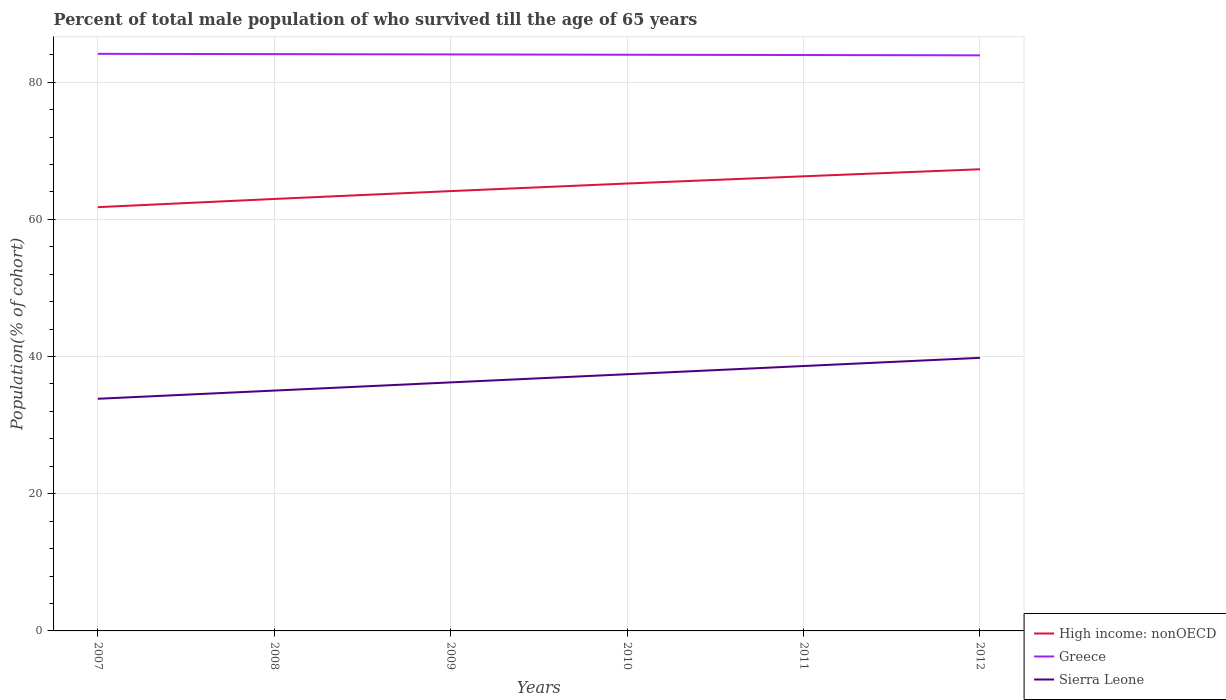Is the number of lines equal to the number of legend labels?
Provide a short and direct response. Yes. Across all years, what is the maximum percentage of total male population who survived till the age of 65 years in High income: nonOECD?
Provide a succinct answer. 61.77. What is the total percentage of total male population who survived till the age of 65 years in Greece in the graph?
Your response must be concise. 0.18. What is the difference between the highest and the second highest percentage of total male population who survived till the age of 65 years in Sierra Leone?
Offer a very short reply. 5.96. Is the percentage of total male population who survived till the age of 65 years in Greece strictly greater than the percentage of total male population who survived till the age of 65 years in High income: nonOECD over the years?
Offer a very short reply. No. How many years are there in the graph?
Offer a terse response. 6. What is the difference between two consecutive major ticks on the Y-axis?
Offer a very short reply. 20. Does the graph contain any zero values?
Your answer should be compact. No. Does the graph contain grids?
Make the answer very short. Yes. How many legend labels are there?
Offer a terse response. 3. How are the legend labels stacked?
Provide a succinct answer. Vertical. What is the title of the graph?
Your answer should be very brief. Percent of total male population of who survived till the age of 65 years. Does "Netherlands" appear as one of the legend labels in the graph?
Your answer should be very brief. No. What is the label or title of the X-axis?
Offer a very short reply. Years. What is the label or title of the Y-axis?
Make the answer very short. Population(% of cohort). What is the Population(% of cohort) in High income: nonOECD in 2007?
Make the answer very short. 61.77. What is the Population(% of cohort) in Greece in 2007?
Offer a very short reply. 84.13. What is the Population(% of cohort) in Sierra Leone in 2007?
Your answer should be compact. 33.84. What is the Population(% of cohort) in High income: nonOECD in 2008?
Keep it short and to the point. 62.97. What is the Population(% of cohort) in Greece in 2008?
Provide a succinct answer. 84.08. What is the Population(% of cohort) in Sierra Leone in 2008?
Make the answer very short. 35.04. What is the Population(% of cohort) of High income: nonOECD in 2009?
Your response must be concise. 64.12. What is the Population(% of cohort) in Greece in 2009?
Your answer should be very brief. 84.04. What is the Population(% of cohort) in Sierra Leone in 2009?
Your answer should be compact. 36.23. What is the Population(% of cohort) in High income: nonOECD in 2010?
Provide a short and direct response. 65.22. What is the Population(% of cohort) in Greece in 2010?
Ensure brevity in your answer.  83.99. What is the Population(% of cohort) in Sierra Leone in 2010?
Your answer should be compact. 37.42. What is the Population(% of cohort) of High income: nonOECD in 2011?
Offer a very short reply. 66.27. What is the Population(% of cohort) in Greece in 2011?
Give a very brief answer. 83.95. What is the Population(% of cohort) in Sierra Leone in 2011?
Give a very brief answer. 38.61. What is the Population(% of cohort) of High income: nonOECD in 2012?
Ensure brevity in your answer.  67.3. What is the Population(% of cohort) in Greece in 2012?
Give a very brief answer. 83.91. What is the Population(% of cohort) of Sierra Leone in 2012?
Offer a terse response. 39.81. Across all years, what is the maximum Population(% of cohort) in High income: nonOECD?
Provide a succinct answer. 67.3. Across all years, what is the maximum Population(% of cohort) of Greece?
Your answer should be compact. 84.13. Across all years, what is the maximum Population(% of cohort) of Sierra Leone?
Ensure brevity in your answer.  39.81. Across all years, what is the minimum Population(% of cohort) in High income: nonOECD?
Your response must be concise. 61.77. Across all years, what is the minimum Population(% of cohort) in Greece?
Your answer should be compact. 83.91. Across all years, what is the minimum Population(% of cohort) of Sierra Leone?
Ensure brevity in your answer.  33.84. What is the total Population(% of cohort) in High income: nonOECD in the graph?
Provide a short and direct response. 387.65. What is the total Population(% of cohort) of Greece in the graph?
Your response must be concise. 504.1. What is the total Population(% of cohort) of Sierra Leone in the graph?
Give a very brief answer. 220.95. What is the difference between the Population(% of cohort) of High income: nonOECD in 2007 and that in 2008?
Your answer should be very brief. -1.2. What is the difference between the Population(% of cohort) of Greece in 2007 and that in 2008?
Offer a terse response. 0.04. What is the difference between the Population(% of cohort) of Sierra Leone in 2007 and that in 2008?
Ensure brevity in your answer.  -1.19. What is the difference between the Population(% of cohort) in High income: nonOECD in 2007 and that in 2009?
Make the answer very short. -2.34. What is the difference between the Population(% of cohort) in Greece in 2007 and that in 2009?
Your response must be concise. 0.09. What is the difference between the Population(% of cohort) of Sierra Leone in 2007 and that in 2009?
Your answer should be very brief. -2.39. What is the difference between the Population(% of cohort) of High income: nonOECD in 2007 and that in 2010?
Your response must be concise. -3.45. What is the difference between the Population(% of cohort) in Greece in 2007 and that in 2010?
Offer a very short reply. 0.13. What is the difference between the Population(% of cohort) of Sierra Leone in 2007 and that in 2010?
Provide a succinct answer. -3.58. What is the difference between the Population(% of cohort) of High income: nonOECD in 2007 and that in 2011?
Keep it short and to the point. -4.5. What is the difference between the Population(% of cohort) of Greece in 2007 and that in 2011?
Your answer should be compact. 0.18. What is the difference between the Population(% of cohort) in Sierra Leone in 2007 and that in 2011?
Provide a succinct answer. -4.77. What is the difference between the Population(% of cohort) of High income: nonOECD in 2007 and that in 2012?
Ensure brevity in your answer.  -5.52. What is the difference between the Population(% of cohort) of Greece in 2007 and that in 2012?
Your response must be concise. 0.22. What is the difference between the Population(% of cohort) in Sierra Leone in 2007 and that in 2012?
Keep it short and to the point. -5.96. What is the difference between the Population(% of cohort) in High income: nonOECD in 2008 and that in 2009?
Your response must be concise. -1.15. What is the difference between the Population(% of cohort) of Greece in 2008 and that in 2009?
Keep it short and to the point. 0.04. What is the difference between the Population(% of cohort) in Sierra Leone in 2008 and that in 2009?
Offer a very short reply. -1.19. What is the difference between the Population(% of cohort) of High income: nonOECD in 2008 and that in 2010?
Your answer should be very brief. -2.25. What is the difference between the Population(% of cohort) in Greece in 2008 and that in 2010?
Your response must be concise. 0.09. What is the difference between the Population(% of cohort) in Sierra Leone in 2008 and that in 2010?
Give a very brief answer. -2.39. What is the difference between the Population(% of cohort) of High income: nonOECD in 2008 and that in 2011?
Give a very brief answer. -3.3. What is the difference between the Population(% of cohort) of Greece in 2008 and that in 2011?
Ensure brevity in your answer.  0.13. What is the difference between the Population(% of cohort) in Sierra Leone in 2008 and that in 2011?
Your answer should be compact. -3.58. What is the difference between the Population(% of cohort) of High income: nonOECD in 2008 and that in 2012?
Your answer should be compact. -4.33. What is the difference between the Population(% of cohort) in Greece in 2008 and that in 2012?
Your answer should be compact. 0.18. What is the difference between the Population(% of cohort) of Sierra Leone in 2008 and that in 2012?
Provide a succinct answer. -4.77. What is the difference between the Population(% of cohort) in High income: nonOECD in 2009 and that in 2010?
Your answer should be compact. -1.1. What is the difference between the Population(% of cohort) in Greece in 2009 and that in 2010?
Make the answer very short. 0.04. What is the difference between the Population(% of cohort) of Sierra Leone in 2009 and that in 2010?
Make the answer very short. -1.19. What is the difference between the Population(% of cohort) in High income: nonOECD in 2009 and that in 2011?
Offer a very short reply. -2.16. What is the difference between the Population(% of cohort) of Greece in 2009 and that in 2011?
Your answer should be very brief. 0.09. What is the difference between the Population(% of cohort) of Sierra Leone in 2009 and that in 2011?
Your response must be concise. -2.39. What is the difference between the Population(% of cohort) in High income: nonOECD in 2009 and that in 2012?
Ensure brevity in your answer.  -3.18. What is the difference between the Population(% of cohort) in Greece in 2009 and that in 2012?
Ensure brevity in your answer.  0.13. What is the difference between the Population(% of cohort) in Sierra Leone in 2009 and that in 2012?
Give a very brief answer. -3.58. What is the difference between the Population(% of cohort) of High income: nonOECD in 2010 and that in 2011?
Provide a succinct answer. -1.05. What is the difference between the Population(% of cohort) of Greece in 2010 and that in 2011?
Offer a terse response. 0.04. What is the difference between the Population(% of cohort) of Sierra Leone in 2010 and that in 2011?
Your answer should be compact. -1.19. What is the difference between the Population(% of cohort) of High income: nonOECD in 2010 and that in 2012?
Your response must be concise. -2.08. What is the difference between the Population(% of cohort) in Greece in 2010 and that in 2012?
Offer a very short reply. 0.09. What is the difference between the Population(% of cohort) in Sierra Leone in 2010 and that in 2012?
Your answer should be very brief. -2.39. What is the difference between the Population(% of cohort) of High income: nonOECD in 2011 and that in 2012?
Offer a terse response. -1.03. What is the difference between the Population(% of cohort) in Greece in 2011 and that in 2012?
Make the answer very short. 0.04. What is the difference between the Population(% of cohort) in Sierra Leone in 2011 and that in 2012?
Give a very brief answer. -1.19. What is the difference between the Population(% of cohort) of High income: nonOECD in 2007 and the Population(% of cohort) of Greece in 2008?
Your answer should be very brief. -22.31. What is the difference between the Population(% of cohort) of High income: nonOECD in 2007 and the Population(% of cohort) of Sierra Leone in 2008?
Give a very brief answer. 26.74. What is the difference between the Population(% of cohort) in Greece in 2007 and the Population(% of cohort) in Sierra Leone in 2008?
Give a very brief answer. 49.09. What is the difference between the Population(% of cohort) of High income: nonOECD in 2007 and the Population(% of cohort) of Greece in 2009?
Ensure brevity in your answer.  -22.26. What is the difference between the Population(% of cohort) in High income: nonOECD in 2007 and the Population(% of cohort) in Sierra Leone in 2009?
Make the answer very short. 25.55. What is the difference between the Population(% of cohort) of Greece in 2007 and the Population(% of cohort) of Sierra Leone in 2009?
Offer a terse response. 47.9. What is the difference between the Population(% of cohort) of High income: nonOECD in 2007 and the Population(% of cohort) of Greece in 2010?
Provide a succinct answer. -22.22. What is the difference between the Population(% of cohort) of High income: nonOECD in 2007 and the Population(% of cohort) of Sierra Leone in 2010?
Your answer should be very brief. 24.35. What is the difference between the Population(% of cohort) of Greece in 2007 and the Population(% of cohort) of Sierra Leone in 2010?
Your answer should be compact. 46.7. What is the difference between the Population(% of cohort) of High income: nonOECD in 2007 and the Population(% of cohort) of Greece in 2011?
Keep it short and to the point. -22.18. What is the difference between the Population(% of cohort) in High income: nonOECD in 2007 and the Population(% of cohort) in Sierra Leone in 2011?
Make the answer very short. 23.16. What is the difference between the Population(% of cohort) in Greece in 2007 and the Population(% of cohort) in Sierra Leone in 2011?
Give a very brief answer. 45.51. What is the difference between the Population(% of cohort) in High income: nonOECD in 2007 and the Population(% of cohort) in Greece in 2012?
Provide a short and direct response. -22.13. What is the difference between the Population(% of cohort) in High income: nonOECD in 2007 and the Population(% of cohort) in Sierra Leone in 2012?
Provide a succinct answer. 21.97. What is the difference between the Population(% of cohort) of Greece in 2007 and the Population(% of cohort) of Sierra Leone in 2012?
Provide a short and direct response. 44.32. What is the difference between the Population(% of cohort) of High income: nonOECD in 2008 and the Population(% of cohort) of Greece in 2009?
Your answer should be compact. -21.07. What is the difference between the Population(% of cohort) in High income: nonOECD in 2008 and the Population(% of cohort) in Sierra Leone in 2009?
Provide a short and direct response. 26.74. What is the difference between the Population(% of cohort) of Greece in 2008 and the Population(% of cohort) of Sierra Leone in 2009?
Your answer should be compact. 47.85. What is the difference between the Population(% of cohort) of High income: nonOECD in 2008 and the Population(% of cohort) of Greece in 2010?
Ensure brevity in your answer.  -21.02. What is the difference between the Population(% of cohort) of High income: nonOECD in 2008 and the Population(% of cohort) of Sierra Leone in 2010?
Make the answer very short. 25.55. What is the difference between the Population(% of cohort) of Greece in 2008 and the Population(% of cohort) of Sierra Leone in 2010?
Offer a very short reply. 46.66. What is the difference between the Population(% of cohort) in High income: nonOECD in 2008 and the Population(% of cohort) in Greece in 2011?
Provide a short and direct response. -20.98. What is the difference between the Population(% of cohort) of High income: nonOECD in 2008 and the Population(% of cohort) of Sierra Leone in 2011?
Your response must be concise. 24.36. What is the difference between the Population(% of cohort) in Greece in 2008 and the Population(% of cohort) in Sierra Leone in 2011?
Provide a succinct answer. 45.47. What is the difference between the Population(% of cohort) of High income: nonOECD in 2008 and the Population(% of cohort) of Greece in 2012?
Offer a terse response. -20.94. What is the difference between the Population(% of cohort) of High income: nonOECD in 2008 and the Population(% of cohort) of Sierra Leone in 2012?
Your answer should be very brief. 23.16. What is the difference between the Population(% of cohort) in Greece in 2008 and the Population(% of cohort) in Sierra Leone in 2012?
Provide a succinct answer. 44.28. What is the difference between the Population(% of cohort) in High income: nonOECD in 2009 and the Population(% of cohort) in Greece in 2010?
Offer a terse response. -19.88. What is the difference between the Population(% of cohort) of High income: nonOECD in 2009 and the Population(% of cohort) of Sierra Leone in 2010?
Your answer should be compact. 26.69. What is the difference between the Population(% of cohort) in Greece in 2009 and the Population(% of cohort) in Sierra Leone in 2010?
Keep it short and to the point. 46.62. What is the difference between the Population(% of cohort) in High income: nonOECD in 2009 and the Population(% of cohort) in Greece in 2011?
Your answer should be very brief. -19.83. What is the difference between the Population(% of cohort) of High income: nonOECD in 2009 and the Population(% of cohort) of Sierra Leone in 2011?
Give a very brief answer. 25.5. What is the difference between the Population(% of cohort) of Greece in 2009 and the Population(% of cohort) of Sierra Leone in 2011?
Give a very brief answer. 45.42. What is the difference between the Population(% of cohort) of High income: nonOECD in 2009 and the Population(% of cohort) of Greece in 2012?
Offer a terse response. -19.79. What is the difference between the Population(% of cohort) in High income: nonOECD in 2009 and the Population(% of cohort) in Sierra Leone in 2012?
Provide a short and direct response. 24.31. What is the difference between the Population(% of cohort) in Greece in 2009 and the Population(% of cohort) in Sierra Leone in 2012?
Make the answer very short. 44.23. What is the difference between the Population(% of cohort) of High income: nonOECD in 2010 and the Population(% of cohort) of Greece in 2011?
Your response must be concise. -18.73. What is the difference between the Population(% of cohort) in High income: nonOECD in 2010 and the Population(% of cohort) in Sierra Leone in 2011?
Your response must be concise. 26.61. What is the difference between the Population(% of cohort) of Greece in 2010 and the Population(% of cohort) of Sierra Leone in 2011?
Your answer should be compact. 45.38. What is the difference between the Population(% of cohort) of High income: nonOECD in 2010 and the Population(% of cohort) of Greece in 2012?
Provide a short and direct response. -18.69. What is the difference between the Population(% of cohort) of High income: nonOECD in 2010 and the Population(% of cohort) of Sierra Leone in 2012?
Keep it short and to the point. 25.41. What is the difference between the Population(% of cohort) in Greece in 2010 and the Population(% of cohort) in Sierra Leone in 2012?
Your response must be concise. 44.19. What is the difference between the Population(% of cohort) of High income: nonOECD in 2011 and the Population(% of cohort) of Greece in 2012?
Your response must be concise. -17.63. What is the difference between the Population(% of cohort) of High income: nonOECD in 2011 and the Population(% of cohort) of Sierra Leone in 2012?
Offer a very short reply. 26.47. What is the difference between the Population(% of cohort) of Greece in 2011 and the Population(% of cohort) of Sierra Leone in 2012?
Your answer should be very brief. 44.14. What is the average Population(% of cohort) of High income: nonOECD per year?
Provide a short and direct response. 64.61. What is the average Population(% of cohort) in Greece per year?
Provide a short and direct response. 84.02. What is the average Population(% of cohort) in Sierra Leone per year?
Give a very brief answer. 36.82. In the year 2007, what is the difference between the Population(% of cohort) of High income: nonOECD and Population(% of cohort) of Greece?
Provide a succinct answer. -22.35. In the year 2007, what is the difference between the Population(% of cohort) of High income: nonOECD and Population(% of cohort) of Sierra Leone?
Your answer should be very brief. 27.93. In the year 2007, what is the difference between the Population(% of cohort) of Greece and Population(% of cohort) of Sierra Leone?
Give a very brief answer. 50.28. In the year 2008, what is the difference between the Population(% of cohort) in High income: nonOECD and Population(% of cohort) in Greece?
Keep it short and to the point. -21.11. In the year 2008, what is the difference between the Population(% of cohort) of High income: nonOECD and Population(% of cohort) of Sierra Leone?
Offer a terse response. 27.93. In the year 2008, what is the difference between the Population(% of cohort) of Greece and Population(% of cohort) of Sierra Leone?
Give a very brief answer. 49.05. In the year 2009, what is the difference between the Population(% of cohort) of High income: nonOECD and Population(% of cohort) of Greece?
Your answer should be very brief. -19.92. In the year 2009, what is the difference between the Population(% of cohort) of High income: nonOECD and Population(% of cohort) of Sierra Leone?
Your answer should be very brief. 27.89. In the year 2009, what is the difference between the Population(% of cohort) of Greece and Population(% of cohort) of Sierra Leone?
Your answer should be very brief. 47.81. In the year 2010, what is the difference between the Population(% of cohort) of High income: nonOECD and Population(% of cohort) of Greece?
Offer a very short reply. -18.77. In the year 2010, what is the difference between the Population(% of cohort) in High income: nonOECD and Population(% of cohort) in Sierra Leone?
Make the answer very short. 27.8. In the year 2010, what is the difference between the Population(% of cohort) of Greece and Population(% of cohort) of Sierra Leone?
Ensure brevity in your answer.  46.57. In the year 2011, what is the difference between the Population(% of cohort) of High income: nonOECD and Population(% of cohort) of Greece?
Your response must be concise. -17.68. In the year 2011, what is the difference between the Population(% of cohort) in High income: nonOECD and Population(% of cohort) in Sierra Leone?
Make the answer very short. 27.66. In the year 2011, what is the difference between the Population(% of cohort) in Greece and Population(% of cohort) in Sierra Leone?
Provide a short and direct response. 45.34. In the year 2012, what is the difference between the Population(% of cohort) of High income: nonOECD and Population(% of cohort) of Greece?
Your answer should be very brief. -16.61. In the year 2012, what is the difference between the Population(% of cohort) of High income: nonOECD and Population(% of cohort) of Sierra Leone?
Make the answer very short. 27.49. In the year 2012, what is the difference between the Population(% of cohort) of Greece and Population(% of cohort) of Sierra Leone?
Make the answer very short. 44.1. What is the ratio of the Population(% of cohort) of High income: nonOECD in 2007 to that in 2009?
Your response must be concise. 0.96. What is the ratio of the Population(% of cohort) of Greece in 2007 to that in 2009?
Your answer should be very brief. 1. What is the ratio of the Population(% of cohort) of Sierra Leone in 2007 to that in 2009?
Your answer should be compact. 0.93. What is the ratio of the Population(% of cohort) in High income: nonOECD in 2007 to that in 2010?
Provide a short and direct response. 0.95. What is the ratio of the Population(% of cohort) of Sierra Leone in 2007 to that in 2010?
Offer a very short reply. 0.9. What is the ratio of the Population(% of cohort) in High income: nonOECD in 2007 to that in 2011?
Ensure brevity in your answer.  0.93. What is the ratio of the Population(% of cohort) of Greece in 2007 to that in 2011?
Your answer should be very brief. 1. What is the ratio of the Population(% of cohort) in Sierra Leone in 2007 to that in 2011?
Provide a succinct answer. 0.88. What is the ratio of the Population(% of cohort) of High income: nonOECD in 2007 to that in 2012?
Your answer should be compact. 0.92. What is the ratio of the Population(% of cohort) in Greece in 2007 to that in 2012?
Your response must be concise. 1. What is the ratio of the Population(% of cohort) of Sierra Leone in 2007 to that in 2012?
Keep it short and to the point. 0.85. What is the ratio of the Population(% of cohort) of High income: nonOECD in 2008 to that in 2009?
Offer a terse response. 0.98. What is the ratio of the Population(% of cohort) of Sierra Leone in 2008 to that in 2009?
Provide a succinct answer. 0.97. What is the ratio of the Population(% of cohort) in High income: nonOECD in 2008 to that in 2010?
Provide a succinct answer. 0.97. What is the ratio of the Population(% of cohort) of Greece in 2008 to that in 2010?
Your answer should be compact. 1. What is the ratio of the Population(% of cohort) in Sierra Leone in 2008 to that in 2010?
Provide a short and direct response. 0.94. What is the ratio of the Population(% of cohort) of High income: nonOECD in 2008 to that in 2011?
Offer a very short reply. 0.95. What is the ratio of the Population(% of cohort) in Greece in 2008 to that in 2011?
Make the answer very short. 1. What is the ratio of the Population(% of cohort) of Sierra Leone in 2008 to that in 2011?
Make the answer very short. 0.91. What is the ratio of the Population(% of cohort) in High income: nonOECD in 2008 to that in 2012?
Make the answer very short. 0.94. What is the ratio of the Population(% of cohort) in Sierra Leone in 2008 to that in 2012?
Offer a very short reply. 0.88. What is the ratio of the Population(% of cohort) of High income: nonOECD in 2009 to that in 2010?
Offer a terse response. 0.98. What is the ratio of the Population(% of cohort) of Greece in 2009 to that in 2010?
Ensure brevity in your answer.  1. What is the ratio of the Population(% of cohort) in Sierra Leone in 2009 to that in 2010?
Give a very brief answer. 0.97. What is the ratio of the Population(% of cohort) of High income: nonOECD in 2009 to that in 2011?
Offer a terse response. 0.97. What is the ratio of the Population(% of cohort) of Greece in 2009 to that in 2011?
Your answer should be very brief. 1. What is the ratio of the Population(% of cohort) of Sierra Leone in 2009 to that in 2011?
Make the answer very short. 0.94. What is the ratio of the Population(% of cohort) of High income: nonOECD in 2009 to that in 2012?
Provide a succinct answer. 0.95. What is the ratio of the Population(% of cohort) in Greece in 2009 to that in 2012?
Ensure brevity in your answer.  1. What is the ratio of the Population(% of cohort) in Sierra Leone in 2009 to that in 2012?
Your response must be concise. 0.91. What is the ratio of the Population(% of cohort) in High income: nonOECD in 2010 to that in 2011?
Your answer should be very brief. 0.98. What is the ratio of the Population(% of cohort) in Sierra Leone in 2010 to that in 2011?
Keep it short and to the point. 0.97. What is the ratio of the Population(% of cohort) in High income: nonOECD in 2010 to that in 2012?
Keep it short and to the point. 0.97. What is the ratio of the Population(% of cohort) of Sierra Leone in 2010 to that in 2012?
Ensure brevity in your answer.  0.94. What is the ratio of the Population(% of cohort) of Greece in 2011 to that in 2012?
Make the answer very short. 1. What is the difference between the highest and the second highest Population(% of cohort) of Greece?
Your answer should be very brief. 0.04. What is the difference between the highest and the second highest Population(% of cohort) of Sierra Leone?
Offer a terse response. 1.19. What is the difference between the highest and the lowest Population(% of cohort) of High income: nonOECD?
Provide a short and direct response. 5.52. What is the difference between the highest and the lowest Population(% of cohort) in Greece?
Keep it short and to the point. 0.22. What is the difference between the highest and the lowest Population(% of cohort) in Sierra Leone?
Make the answer very short. 5.96. 